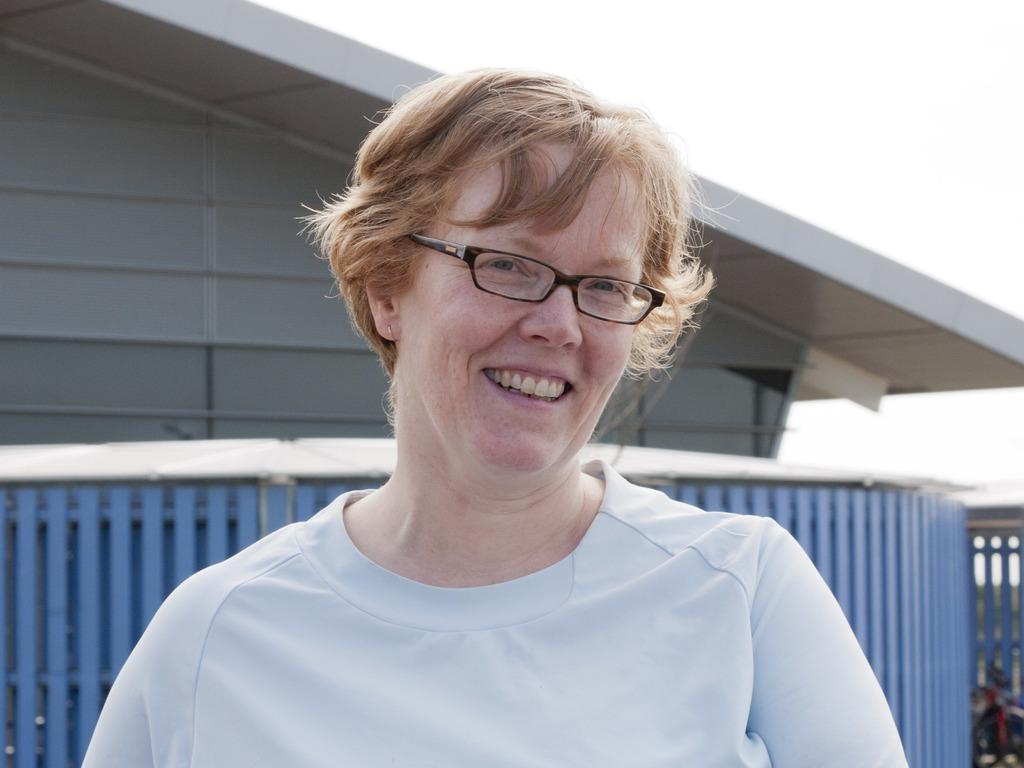What is the appearance of the woman in the image? There is a blond haired old woman in the image. What is the woman wearing? The woman is wearing a white t-shirt. Where is the woman positioned in the image? The woman is standing in the front of the image. What can be seen in the background of the image? There is a home in the background of the image, and there is a fence around the home. What is visible above the home in the image? The sky is visible above the home. What subject is the woman attempting to teach in the image? There is no indication in the image that the woman is attempting to teach any subject. Who is the owner of the home in the background of the image? The image does not provide information about the ownership of the home in the background. 